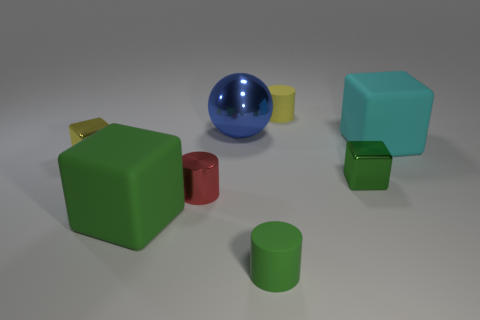There is a large rubber thing behind the tiny green block; is its shape the same as the tiny green metallic object?
Give a very brief answer. Yes. How many other objects are the same shape as the tiny green shiny object?
Offer a very short reply. 3. There is a red metal object on the left side of the tiny yellow rubber cylinder; what is its shape?
Your response must be concise. Cylinder. Is there another small cylinder made of the same material as the yellow cylinder?
Make the answer very short. Yes. Is the color of the matte cylinder that is behind the small yellow metallic object the same as the big sphere?
Make the answer very short. No. The red cylinder is what size?
Offer a terse response. Small. Are there any shiny blocks behind the yellow object to the right of the yellow metallic block that is behind the large green matte object?
Keep it short and to the point. No. There is a tiny green matte object; what number of matte things are on the right side of it?
Your response must be concise. 2. What number of shiny objects are the same color as the ball?
Your answer should be compact. 0. What number of things are either yellow shiny blocks to the left of the blue sphere or small metal objects that are right of the large green rubber cube?
Offer a terse response. 3. 